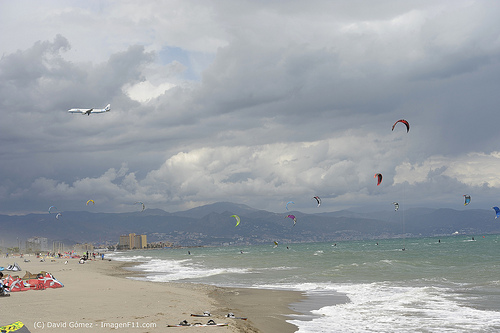Please provide the bounding box coordinate of the region this sentence describes: this is an airplane. The bounding box coordinates for the region described as 'this is an airplane' are [0.13, 0.36, 0.23, 0.41]. 